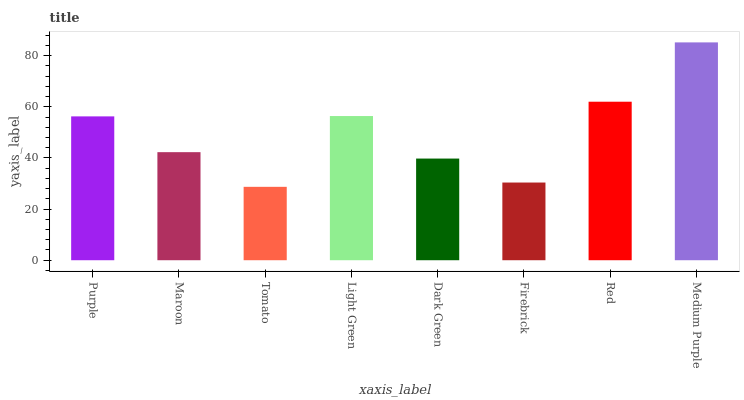Is Maroon the minimum?
Answer yes or no. No. Is Maroon the maximum?
Answer yes or no. No. Is Purple greater than Maroon?
Answer yes or no. Yes. Is Maroon less than Purple?
Answer yes or no. Yes. Is Maroon greater than Purple?
Answer yes or no. No. Is Purple less than Maroon?
Answer yes or no. No. Is Purple the high median?
Answer yes or no. Yes. Is Maroon the low median?
Answer yes or no. Yes. Is Dark Green the high median?
Answer yes or no. No. Is Red the low median?
Answer yes or no. No. 